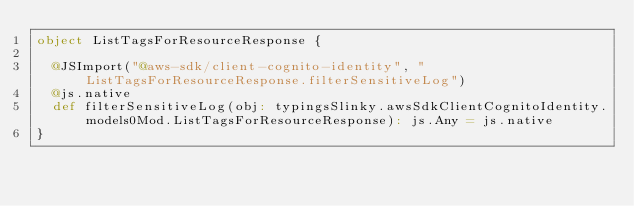<code> <loc_0><loc_0><loc_500><loc_500><_Scala_>object ListTagsForResourceResponse {
  
  @JSImport("@aws-sdk/client-cognito-identity", "ListTagsForResourceResponse.filterSensitiveLog")
  @js.native
  def filterSensitiveLog(obj: typingsSlinky.awsSdkClientCognitoIdentity.models0Mod.ListTagsForResourceResponse): js.Any = js.native
}
</code> 